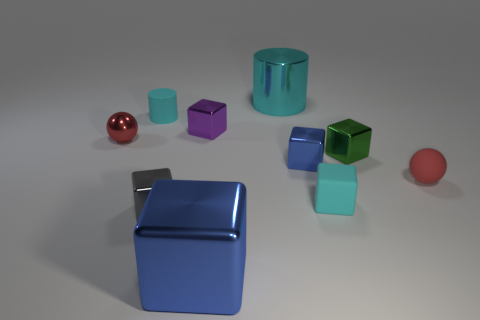What can you tell me about the colors of the objects? The objects come in various colors, including red, purple, green, blue, cyan, and one object with a metallic sheen. Which object stands out the most? The red sphere stands out due to its vibrant color and shiny surface, which contrasts with the other matte objects. 